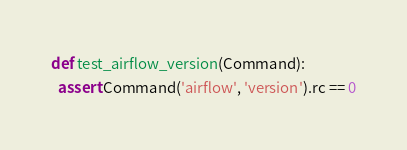Convert code to text. <code><loc_0><loc_0><loc_500><loc_500><_Python_>def test_airflow_version(Command):
  assert Command('airflow', 'version').rc == 0
</code> 